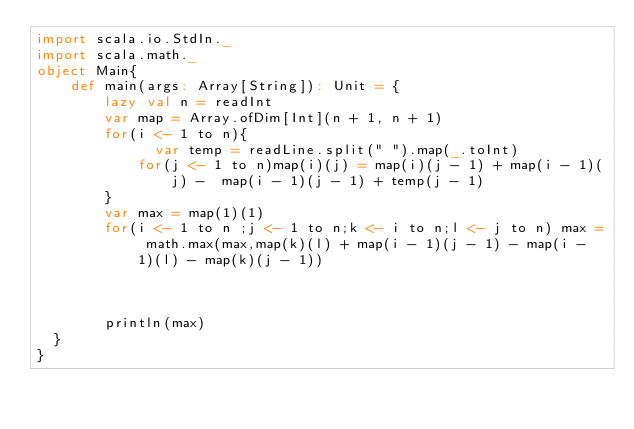Convert code to text. <code><loc_0><loc_0><loc_500><loc_500><_Scala_>import scala.io.StdIn._
import scala.math._
object Main{
    def main(args: Array[String]): Unit = {
        lazy val n = readInt
        var map = Array.ofDim[Int](n + 1, n + 1)
        for(i <- 1 to n){
              var temp = readLine.split(" ").map(_.toInt)
            for(j <- 1 to n)map(i)(j) = map(i)(j - 1) + map(i - 1)(j) -  map(i - 1)(j - 1) + temp(j - 1)
        }
        var max = map(1)(1)
        for(i <- 1 to n ;j <- 1 to n;k <- i to n;l <- j to n) max = math.max(max,map(k)(l) + map(i - 1)(j - 1) - map(i - 1)(l) - map(k)(j - 1))   
        
        
        
        println(max)
  }
}</code> 